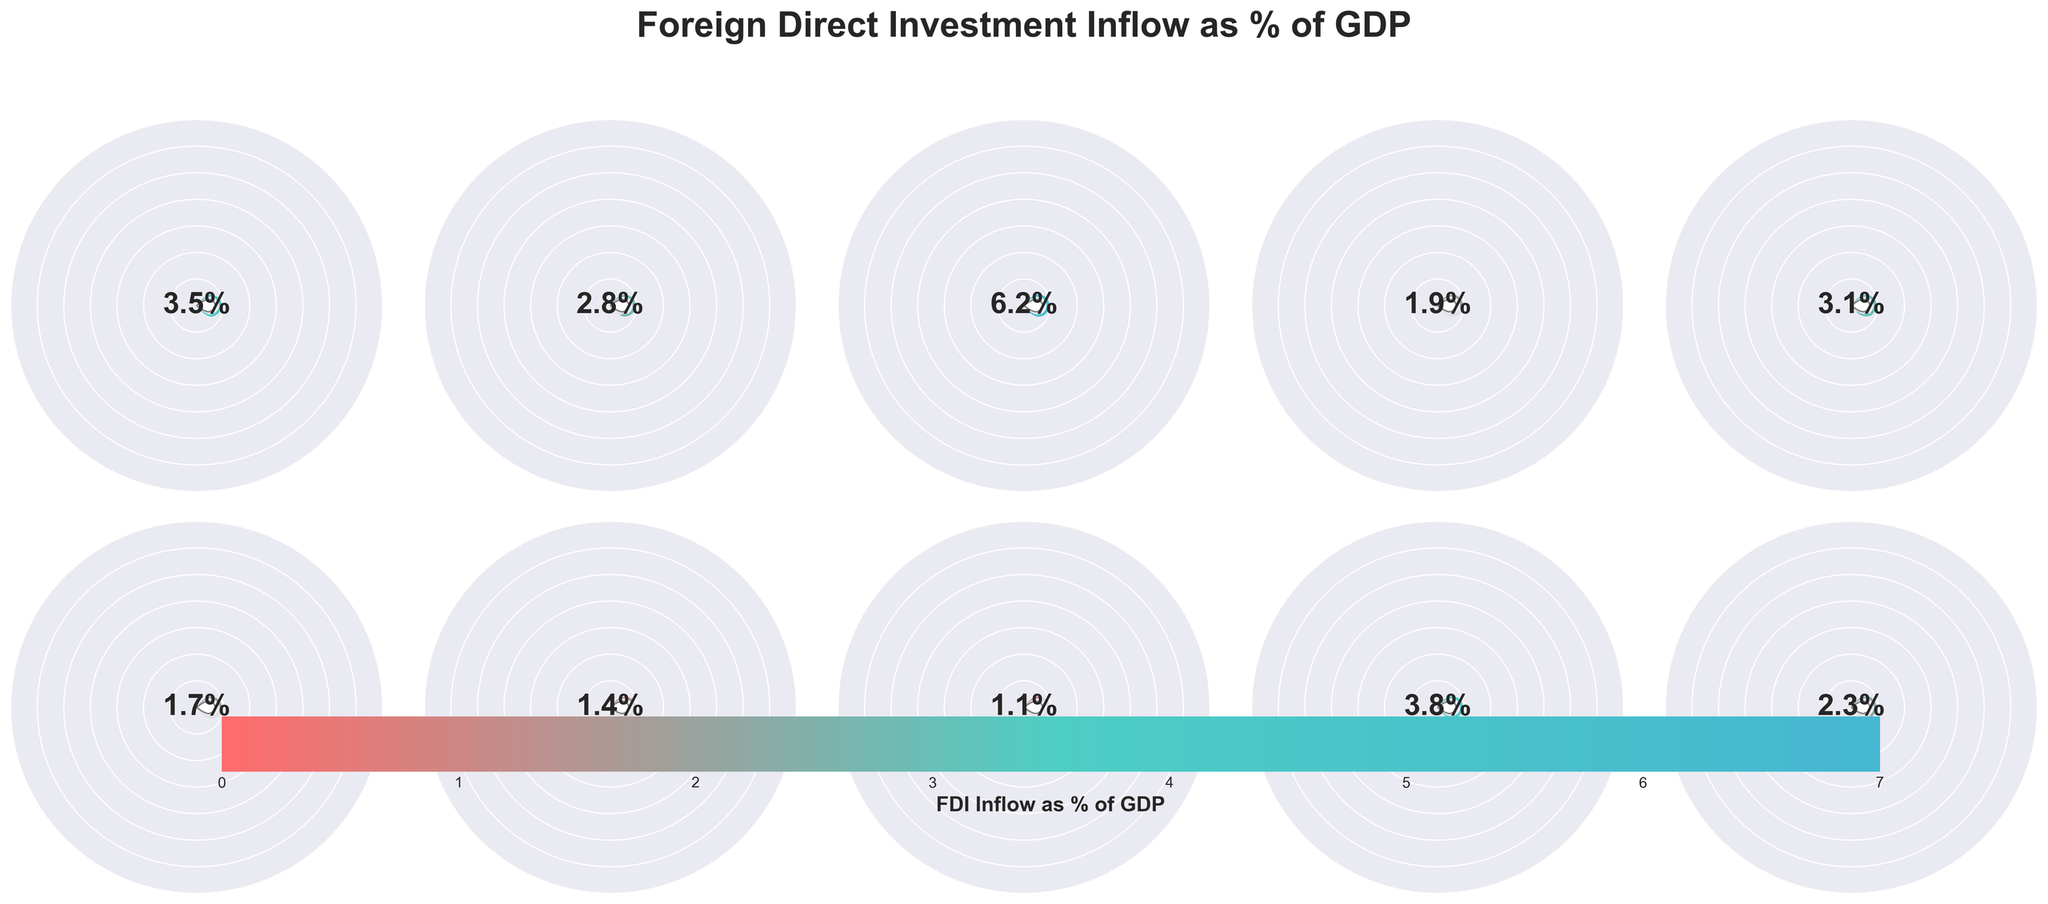What is the title of the figure? The title of the figure is centrally located at the top and reads "Foreign Direct Investment Inflow as % of GDP", indicating the main subject of the visualization.
Answer: Foreign Direct Investment Inflow as % of GDP Which country has the highest FDI Inflow percentage? By looking at the figure, you can see that Vietnam's gauge is the fullest, showing the highest FDI Inflow percentage among the listed countries.
Answer: Vietnam What is the FDI Inflow percentage for India? The gauge for India shows a value near 2.8% FDI Inflow as it is labelled within the central circle around that value.
Answer: 2.8% How many countries have an FDI Inflow percentage greater than 3%? By examining the fullness of gauges, you can count the countries whose gauges display a value above 3%. These countries are Brazil, Vietnam, Mexico, and Malaysia. Hence, there are 4 countries in total.
Answer: 4 Which countries have an FDI Inflow percentage lower than 2%? The countries with gauges showing less than 2% are Indonesia, Turkey, South Africa, and Thailand.
Answer: Indonesia, Turkey, South Africa, Thailand What is the average FDI Inflow percentage among the listed countries? To calculate, you sum the FDI values (3.5 + 2.8 + 6.2 + 1.9 + 3.1 + 1.7 + 1.4 + 1.1 + 3.8 + 2.3) to get a total of 27.8, then divide by the number of countries, which is 10. The average is 27.8 / 10 = 2.78.
Answer: 2.78% Which region does the color scale suggest as having a higher FDI Inflow: #FF6B6B or #45B7D1? The color scale on the horizontal color bar indicates that #45B7D1 is associated with higher FDI values compared to #FF6B6B.
Answer: #45B7D1 What range of FDI Inflow percentages is displayed by the gauges? The gauges visually display a range of FDI Inflows from 0% up to about 7%, as evident from the outer circles marked with number positions indicating the scale.
Answer: 0% - 7% Which country's gauge shows a similar FDI Inflow percentage to the Philippines? Mexico's gauge is close in size to the Philippines' gauge, indicating they have similar FDI Inflow percentages.
Answer: Mexico How does Turkey's FDI Inflow percentage compare to Malaysia's? Comparing the two gauges, Turkey has a noticeably smaller gauge indicating an FDI Inflow of 1.7%, while Malaysia has a larger gauge showing 3.8%. Thus, Malaysia has a significantly higher FDI Inflow percentage than Turkey.
Answer: Malaysia has a higher FDI Inflow percentage than Turkey 